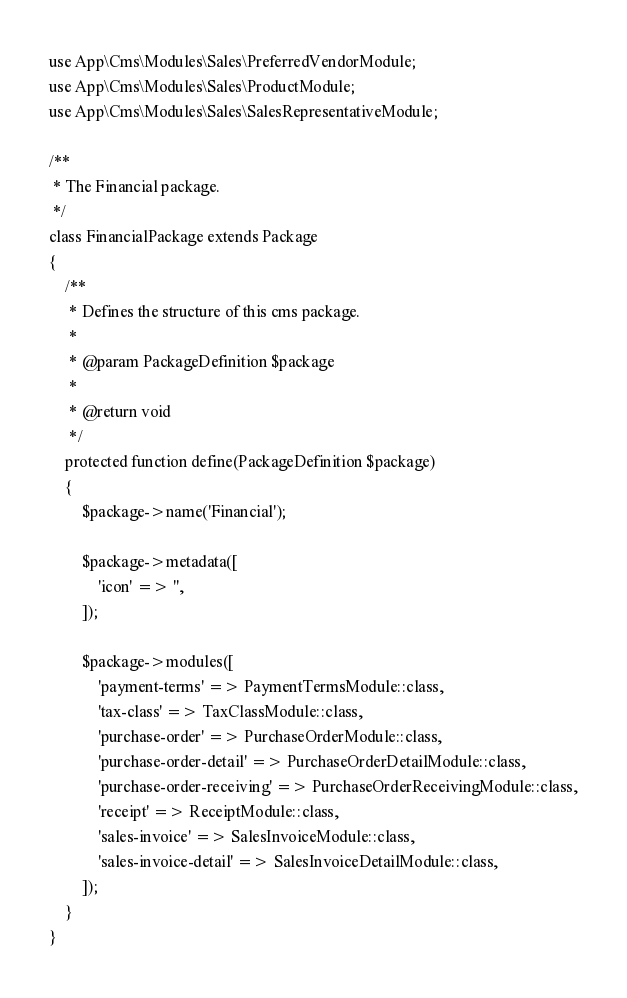<code> <loc_0><loc_0><loc_500><loc_500><_PHP_>use App\Cms\Modules\Sales\PreferredVendorModule;
use App\Cms\Modules\Sales\ProductModule;
use App\Cms\Modules\Sales\SalesRepresentativeModule;

/**
 * The Financial package.
 */
class FinancialPackage extends Package
{
    /**
     * Defines the structure of this cms package.
     *
     * @param PackageDefinition $package
     *
     * @return void
     */
    protected function define(PackageDefinition $package)
    {
        $package->name('Financial');

        $package->metadata([
            'icon' => '',
        ]);

        $package->modules([
            'payment-terms' => PaymentTermsModule::class,
            'tax-class' => TaxClassModule::class,
            'purchase-order' => PurchaseOrderModule::class,
            'purchase-order-detail' => PurchaseOrderDetailModule::class,
            'purchase-order-receiving' => PurchaseOrderReceivingModule::class,
            'receipt' => ReceiptModule::class,
            'sales-invoice' => SalesInvoiceModule::class,
            'sales-invoice-detail' => SalesInvoiceDetailModule::class,
        ]);
    }
}
</code> 